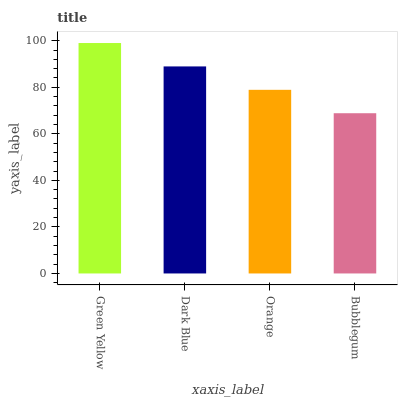Is Bubblegum the minimum?
Answer yes or no. Yes. Is Green Yellow the maximum?
Answer yes or no. Yes. Is Dark Blue the minimum?
Answer yes or no. No. Is Dark Blue the maximum?
Answer yes or no. No. Is Green Yellow greater than Dark Blue?
Answer yes or no. Yes. Is Dark Blue less than Green Yellow?
Answer yes or no. Yes. Is Dark Blue greater than Green Yellow?
Answer yes or no. No. Is Green Yellow less than Dark Blue?
Answer yes or no. No. Is Dark Blue the high median?
Answer yes or no. Yes. Is Orange the low median?
Answer yes or no. Yes. Is Bubblegum the high median?
Answer yes or no. No. Is Dark Blue the low median?
Answer yes or no. No. 